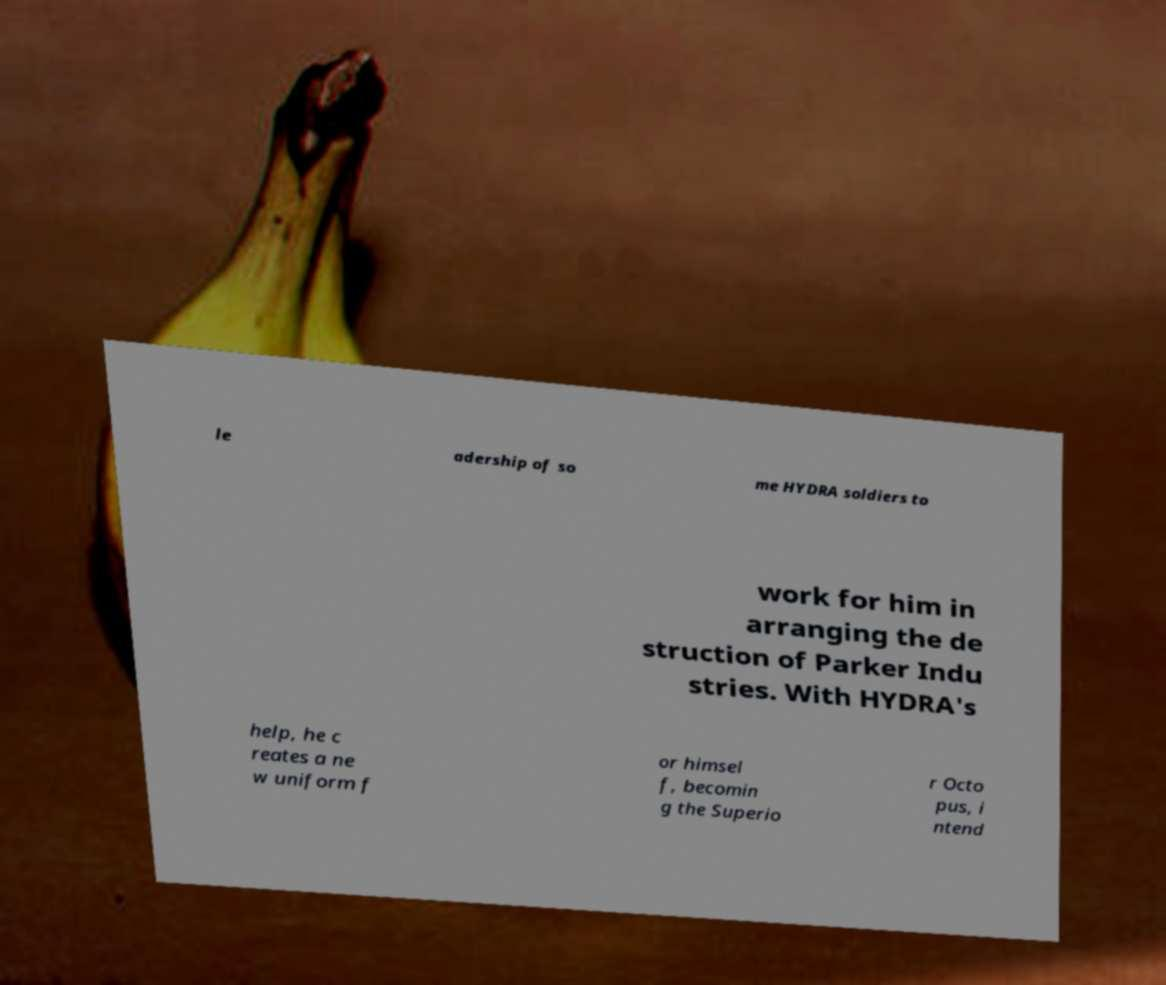There's text embedded in this image that I need extracted. Can you transcribe it verbatim? le adership of so me HYDRA soldiers to work for him in arranging the de struction of Parker Indu stries. With HYDRA's help, he c reates a ne w uniform f or himsel f, becomin g the Superio r Octo pus, i ntend 